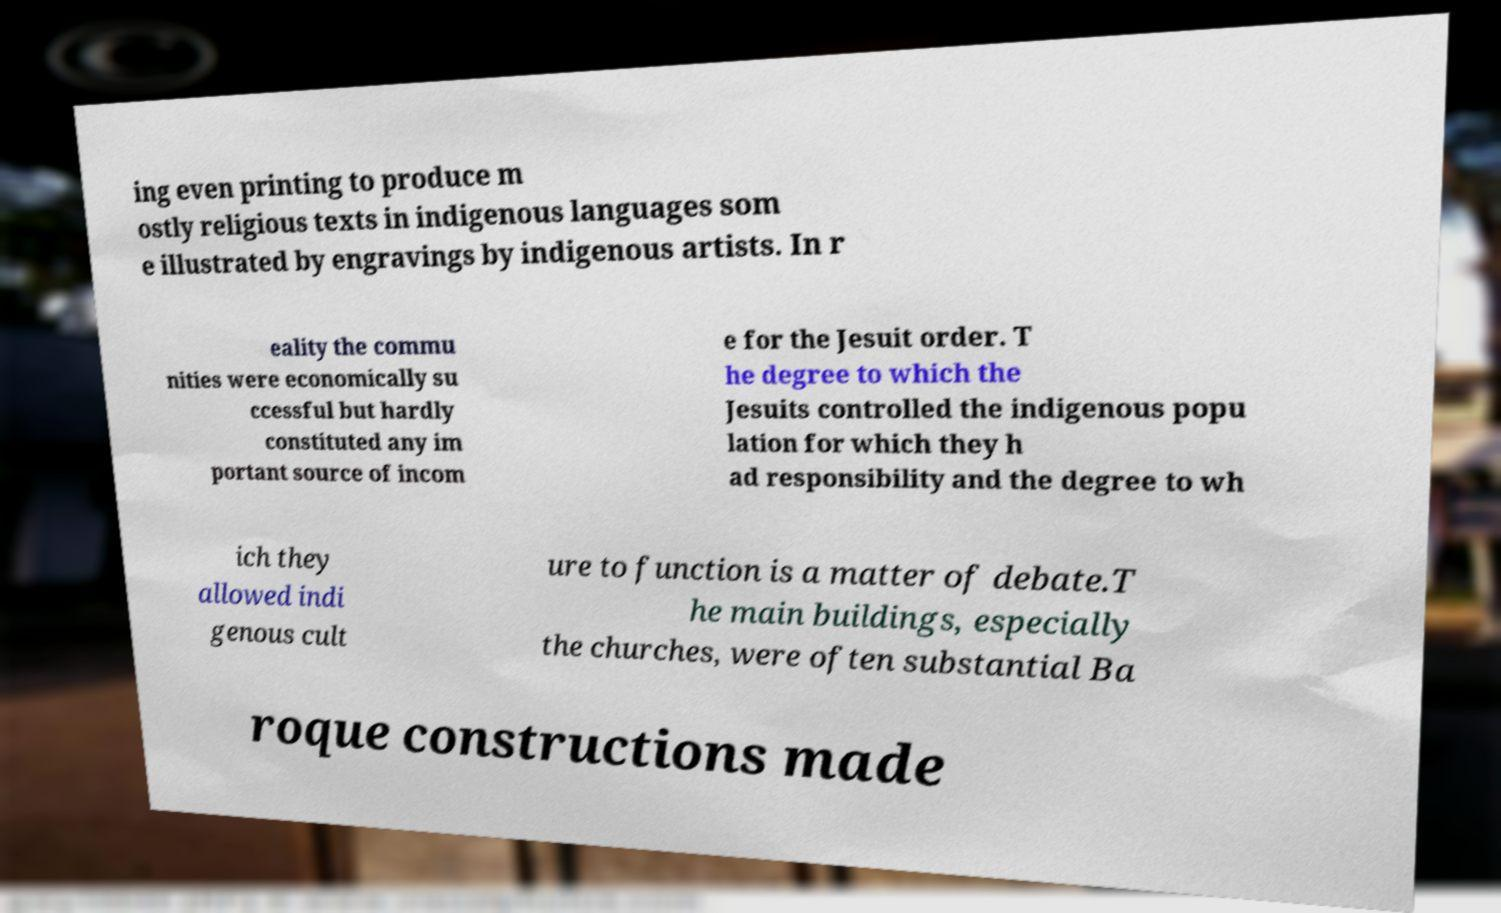Please identify and transcribe the text found in this image. ing even printing to produce m ostly religious texts in indigenous languages som e illustrated by engravings by indigenous artists. In r eality the commu nities were economically su ccessful but hardly constituted any im portant source of incom e for the Jesuit order. T he degree to which the Jesuits controlled the indigenous popu lation for which they h ad responsibility and the degree to wh ich they allowed indi genous cult ure to function is a matter of debate.T he main buildings, especially the churches, were often substantial Ba roque constructions made 